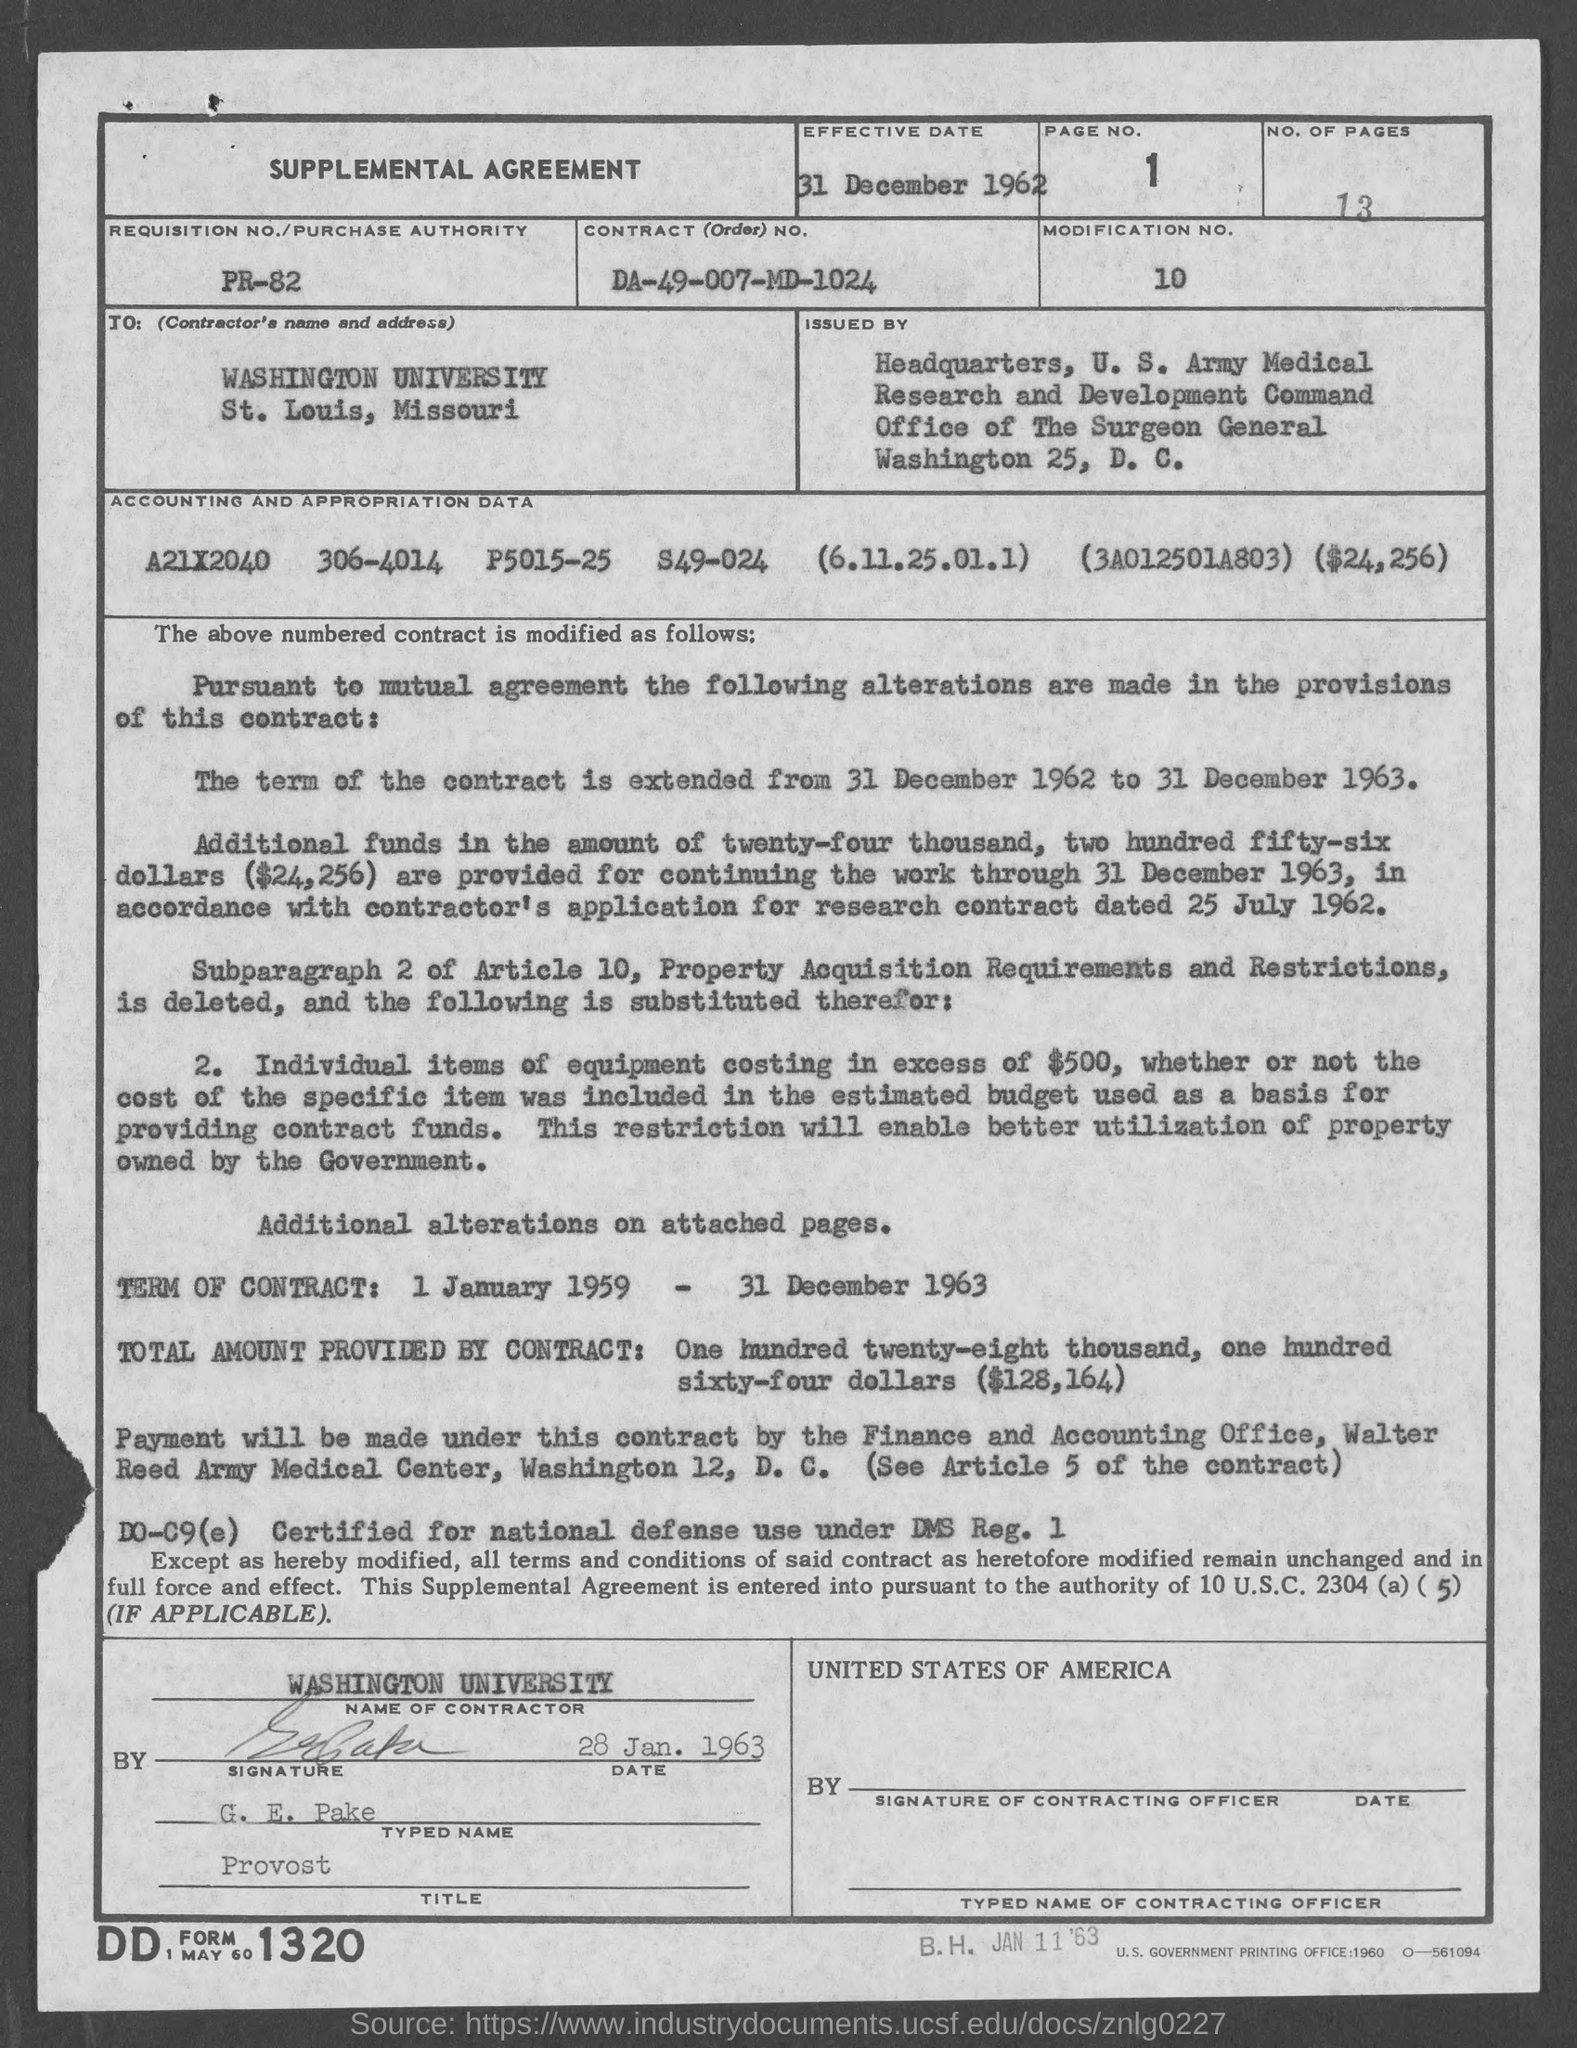Can you provide the effective date mentioned in this document? The document states the effective date as 31 December 1962, which is located at the top of the page under 'EFFECTIVE DATE.' 